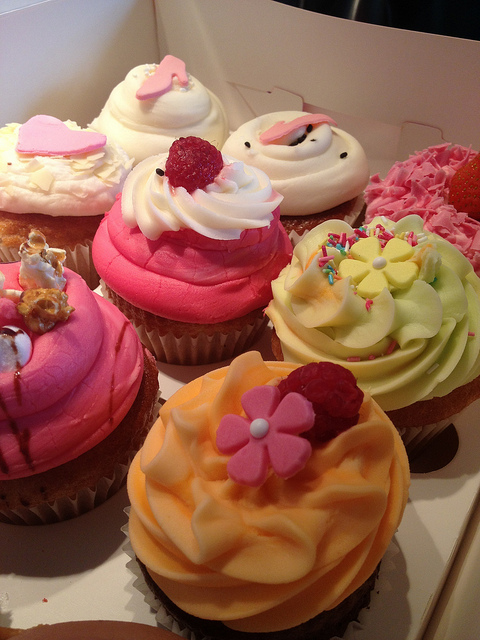How many cupcakes are in the photo? There are six beautifully decorated cupcakes in the photo, each adorned with various toppings like raspberries, sprinkles, and candy hearts, making them not only a sweet treat but also a feast for the eyes. 